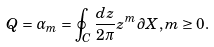<formula> <loc_0><loc_0><loc_500><loc_500>Q = \alpha _ { m } = \oint _ { C } \frac { d z } { 2 \pi } z ^ { m } \partial X , m \geq 0 .</formula> 